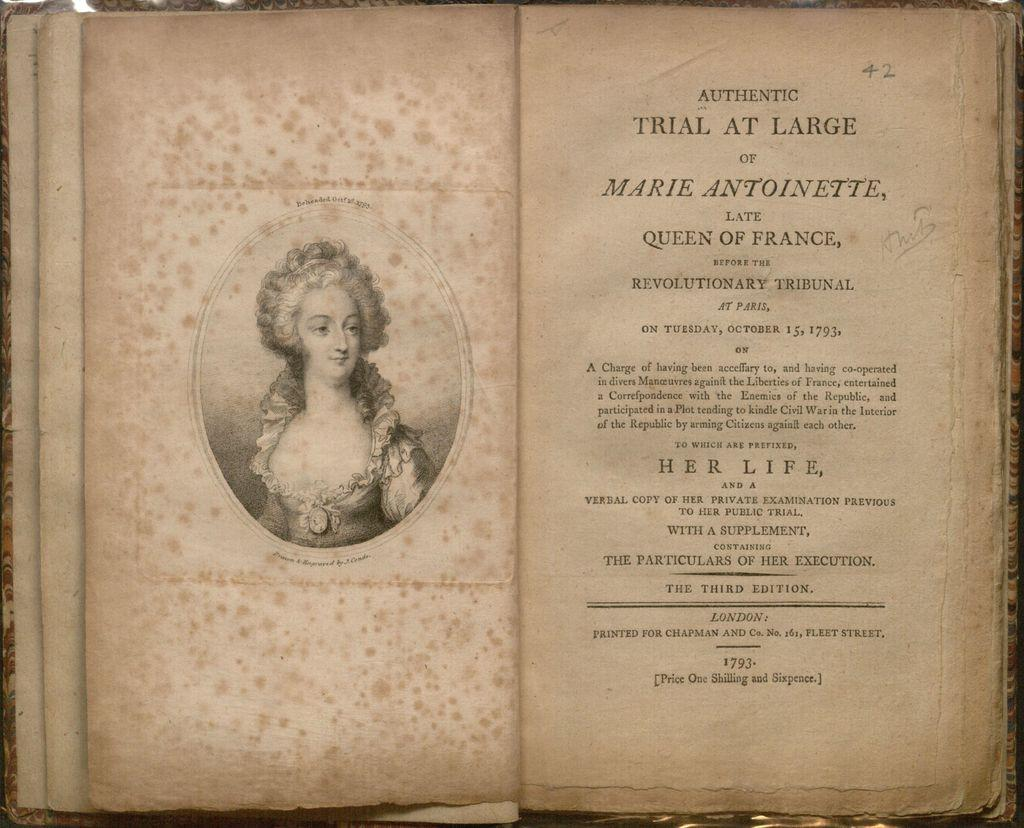What is the main object in the image? There is a book in the image. What else can be seen on the paper in the image? There is text written on a paper in the image. What type of drawing is present in the image? There is a sketch of a woman in the image. What type of punishment is being depicted in the sketch of the woman in the image? There is no punishment being depicted in the sketch of the woman in the image; it is simply a drawing of a woman. What type of bird can be seen flying in the image? There is no bird present in the image. 